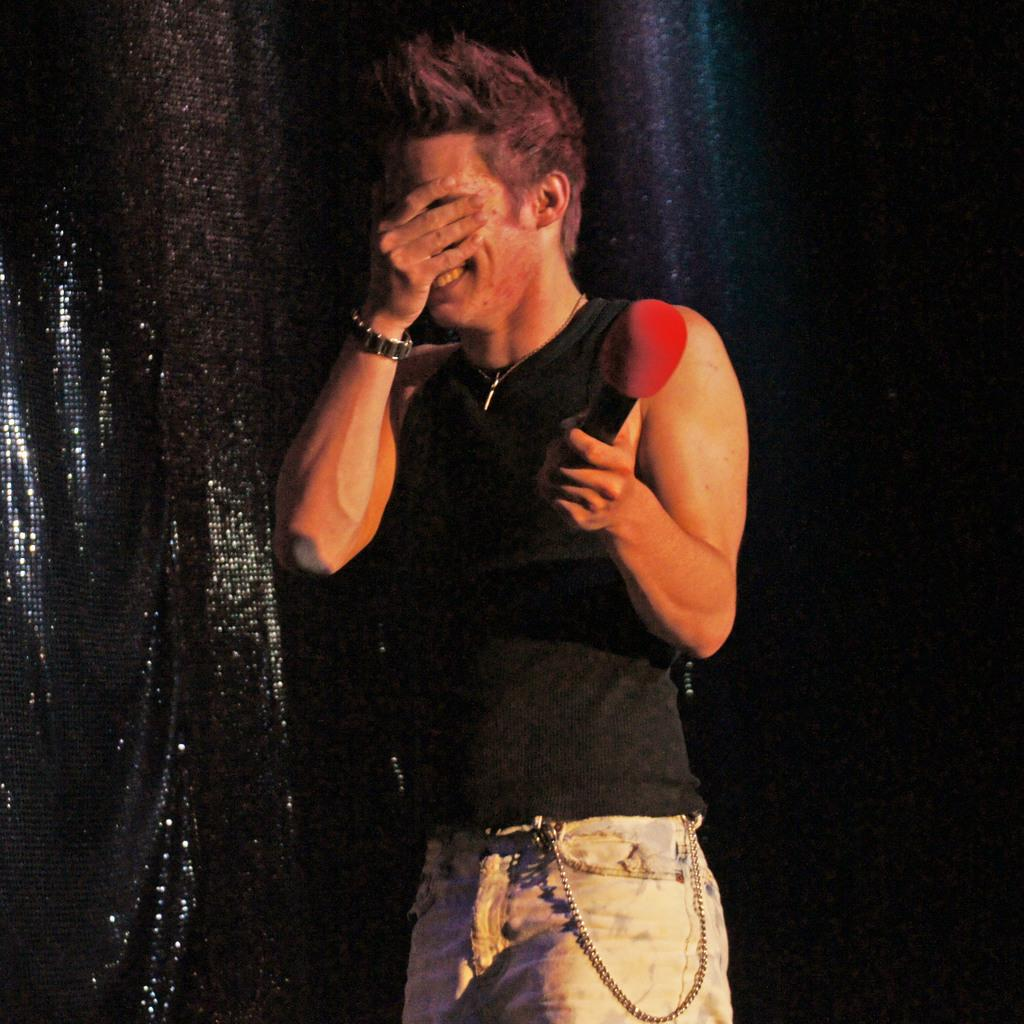What is the main subject of the image? The main subject of the image is a man. What is the man doing in the image? The man is standing and holding a microphone. How is the man's facial expression in the image? The man has a smile on his face. What is the man doing with his hand in the image? The man has covered his face with his hand. What type of oil can be seen dripping from the microphone in the image? There is no oil present in the image, and the microphone is not shown to be dripping anything. 